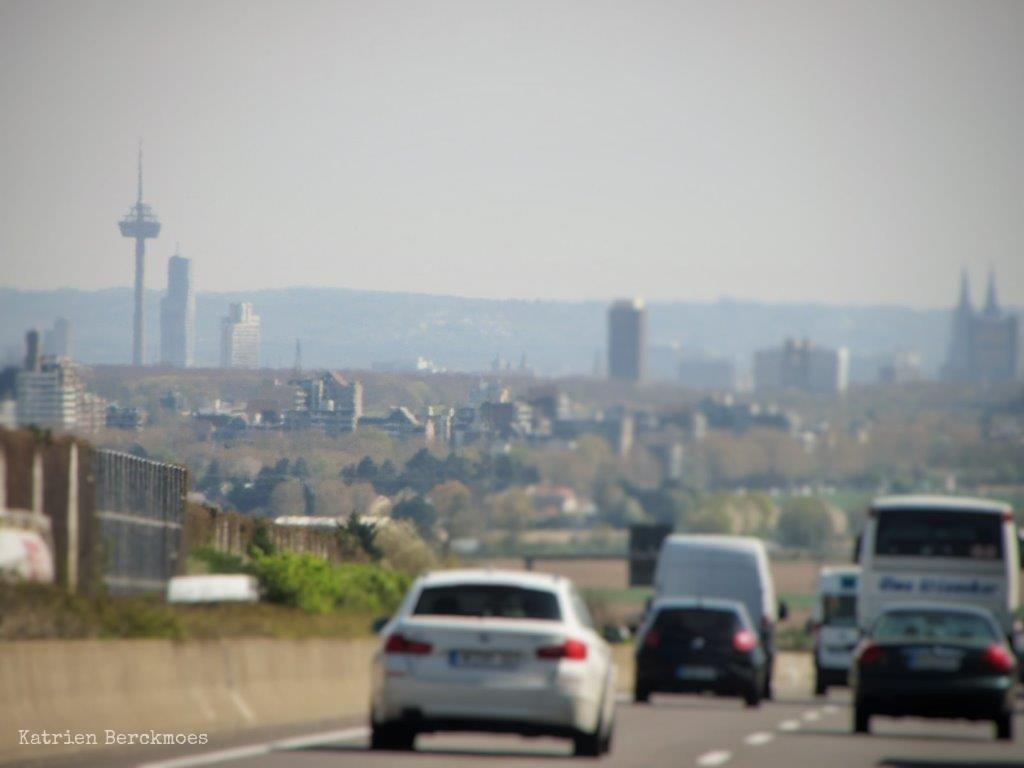What is happening on the road in the image? There are cars travelling on the road in the image. What can be seen beside the road? There are trees beside the road. What is the purpose of the fence in the image? The fence is present in the image, but its purpose cannot be determined from the provided facts. What structures are in front of the road? There are buildings in front of the road. What type of natural landscape is visible in the image? Mountains are visible in the image. What is visible at the top of the image? The sky is visible at the top of the image. How many dogs are playing in the rain in the image? There are no dogs or rain present in the image; it features cars travelling on a road with trees, a fence, buildings, mountains, and the sky visible. What type of nut can be seen growing on the trees in the image? There is no mention of nuts or trees with nuts in the provided facts; the trees are simply described as being beside the road. 